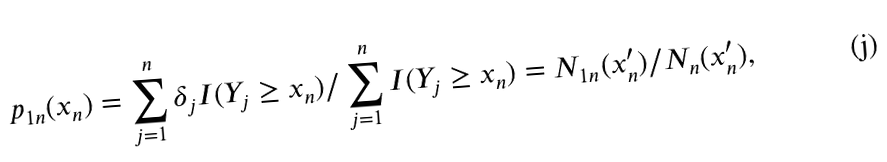Convert formula to latex. <formula><loc_0><loc_0><loc_500><loc_500>p _ { 1 n } ( x _ { n } ) = \sum _ { j = 1 } ^ { n } \delta _ { j } I ( Y _ { j } \geq x _ { n } ) / \sum _ { j = 1 } ^ { n } I ( Y _ { j } \geq x _ { n } ) = N _ { 1 n } ( x ^ { \prime } _ { n } ) / N _ { n } ( x ^ { \prime } _ { n } ) ,</formula> 